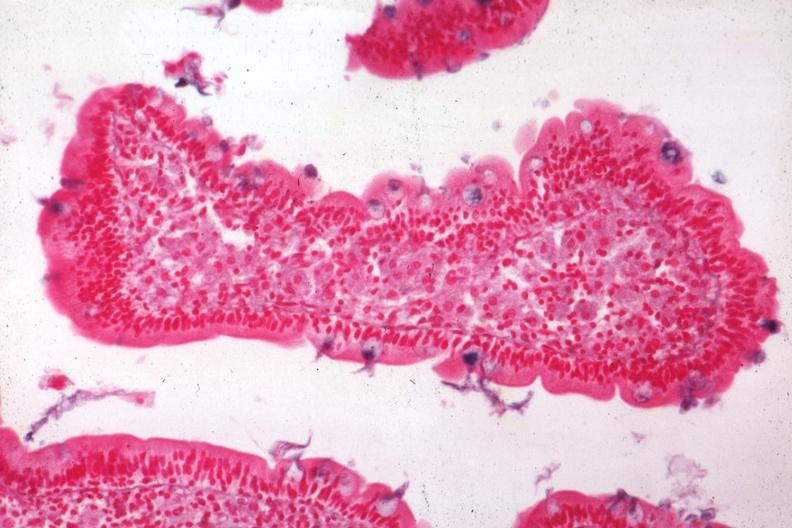where is this from?
Answer the question using a single word or phrase. Gastrointestinal system 